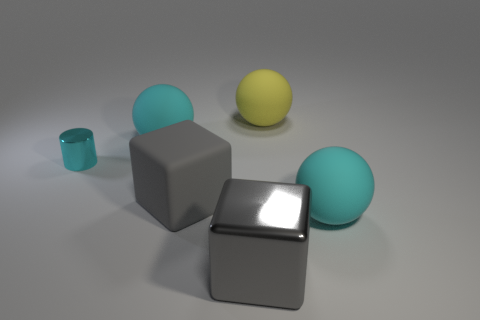Add 4 big purple spheres. How many objects exist? 10 Subtract all blocks. How many objects are left? 4 Subtract 0 purple cubes. How many objects are left? 6 Subtract all small red shiny spheres. Subtract all large gray matte blocks. How many objects are left? 5 Add 6 cubes. How many cubes are left? 8 Add 3 small cyan objects. How many small cyan objects exist? 4 